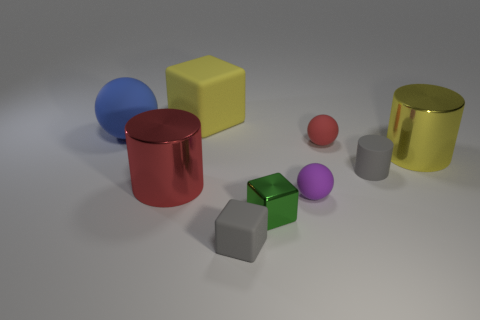Subtract all cylinders. How many objects are left? 6 Subtract all small yellow metallic cubes. Subtract all shiny objects. How many objects are left? 6 Add 3 purple balls. How many purple balls are left? 4 Add 7 large blue rubber spheres. How many large blue rubber spheres exist? 8 Subtract 0 purple blocks. How many objects are left? 9 